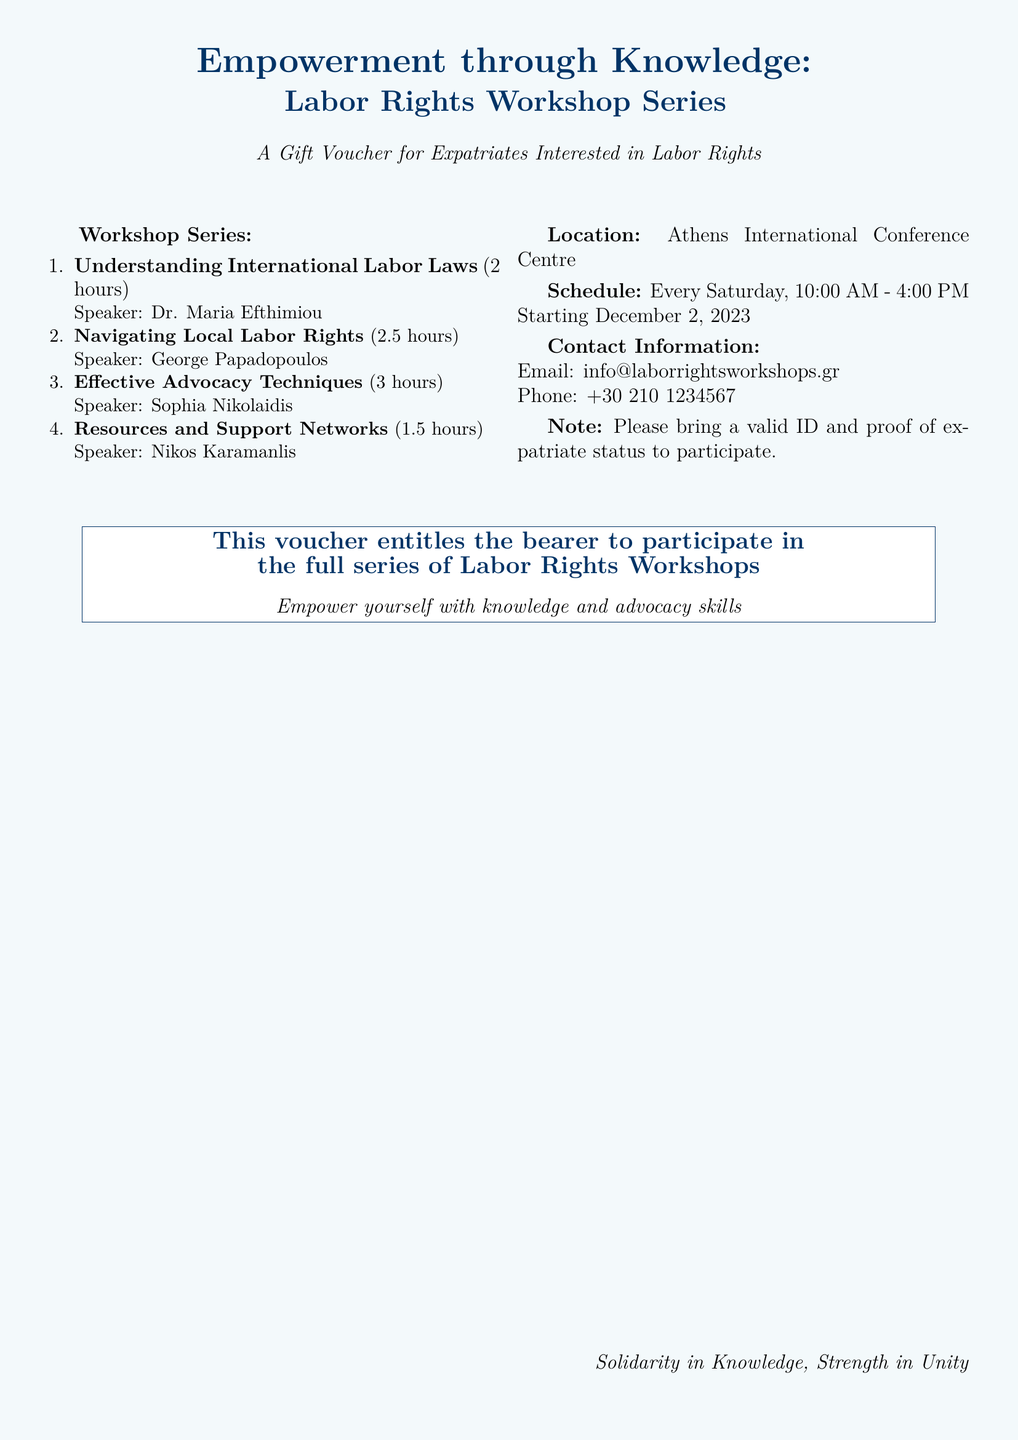What are the dates of the workshop series? The document states that the workshops start on December 2, 2023, and occur every Saturday.
Answer: December 2, 2023 Who is the speaker for the "Effective Advocacy Techniques" workshop? The name of the speaker for this workshop is provided in the document.
Answer: Sophia Nikolaidis How long is the "Navigating Local Labor Rights" workshop? The duration of the workshop is mentioned alongside its title.
Answer: 2.5 hours What is the location of the workshops? The document specifies where the workshops will take place.
Answer: Athens International Conference Centre What should participants bring to the workshops? The document includes specific items that participants need to bring for participation.
Answer: Valid ID and proof of expatriate status What is the total duration of the workshop series? The total duration can be calculated by adding the hours of each individual workshop listed in the document.
Answer: 9 hours How many workshops are included in the series? The document outlines the number of workshops in the series.
Answer: Four What is the primary purpose of the workshops? The overarching goal of the workshops is stated in the document through its title.
Answer: Empowerment through knowledge What is the contact email for the workshops? The document provides contact details, including an email address.
Answer: info@laborrightsworkshops.gr 